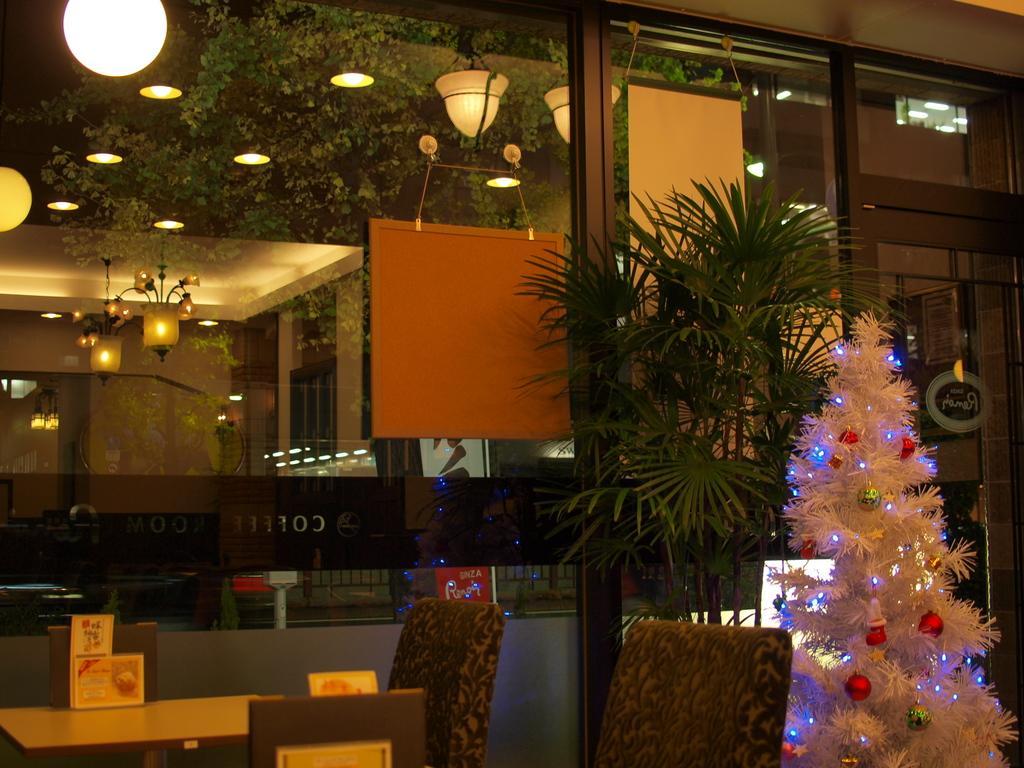Describe this image in one or two sentences. In this picture I can see the building. In the bottom right corner I can see the plants and Christmas tree. In the bottom left corner I can see the table and chairs. On the left I can see some chandeliers which are hanging on the roof. In the top right there is a door. 